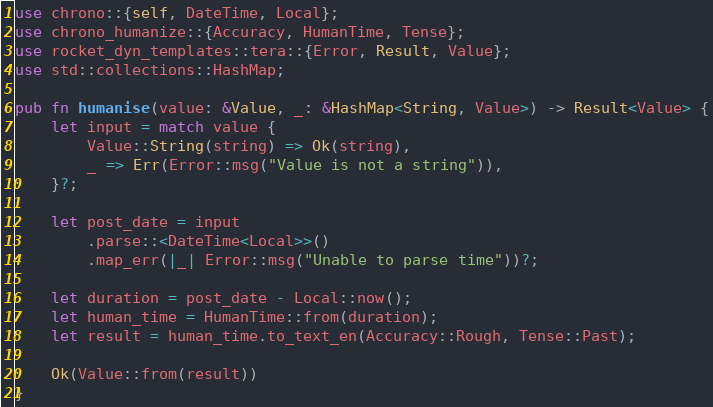<code> <loc_0><loc_0><loc_500><loc_500><_Rust_>use chrono::{self, DateTime, Local};
use chrono_humanize::{Accuracy, HumanTime, Tense};
use rocket_dyn_templates::tera::{Error, Result, Value};
use std::collections::HashMap;

pub fn humanise(value: &Value, _: &HashMap<String, Value>) -> Result<Value> {
    let input = match value {
        Value::String(string) => Ok(string),
        _ => Err(Error::msg("Value is not a string")),
    }?;

    let post_date = input
        .parse::<DateTime<Local>>()
        .map_err(|_| Error::msg("Unable to parse time"))?;

    let duration = post_date - Local::now();
    let human_time = HumanTime::from(duration);
    let result = human_time.to_text_en(Accuracy::Rough, Tense::Past);

    Ok(Value::from(result))
}
</code> 